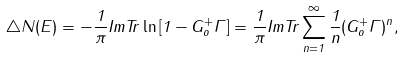Convert formula to latex. <formula><loc_0><loc_0><loc_500><loc_500>\triangle N ( E ) = - \frac { 1 } { \pi } I m T r \ln \left [ 1 - G _ { o } ^ { + } \Gamma \right ] = \frac { 1 } { \pi } I m T r \sum _ { n = 1 } ^ { \infty } \frac { 1 } { n } ( G _ { o } ^ { + } \Gamma ) ^ { n } ,</formula> 